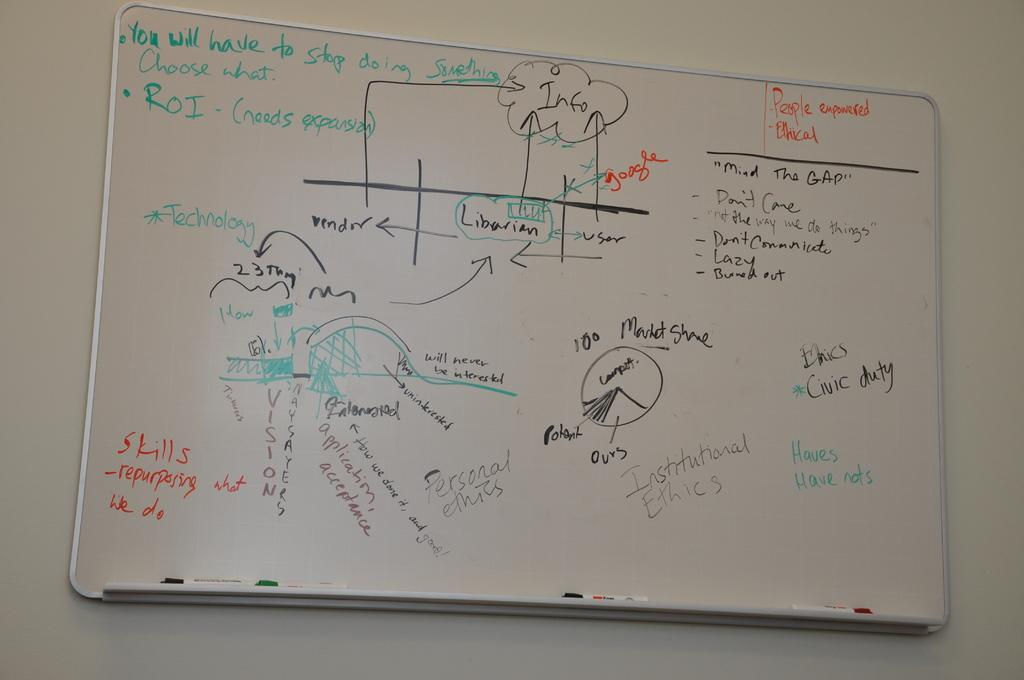<image>
Relay a brief, clear account of the picture shown. White board that says "People Empowered" in red. 